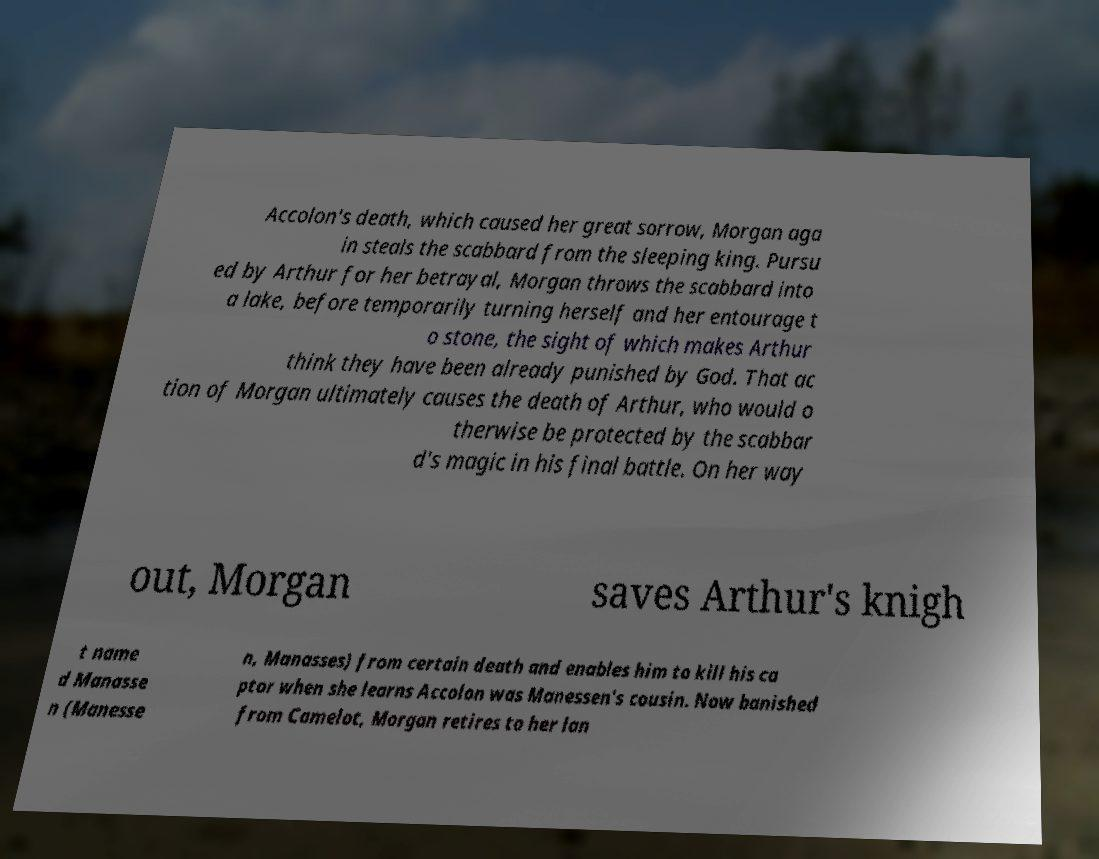Could you assist in decoding the text presented in this image and type it out clearly? Accolon's death, which caused her great sorrow, Morgan aga in steals the scabbard from the sleeping king. Pursu ed by Arthur for her betrayal, Morgan throws the scabbard into a lake, before temporarily turning herself and her entourage t o stone, the sight of which makes Arthur think they have been already punished by God. That ac tion of Morgan ultimately causes the death of Arthur, who would o therwise be protected by the scabbar d's magic in his final battle. On her way out, Morgan saves Arthur's knigh t name d Manasse n (Manesse n, Manasses) from certain death and enables him to kill his ca ptor when she learns Accolon was Manessen's cousin. Now banished from Camelot, Morgan retires to her lan 